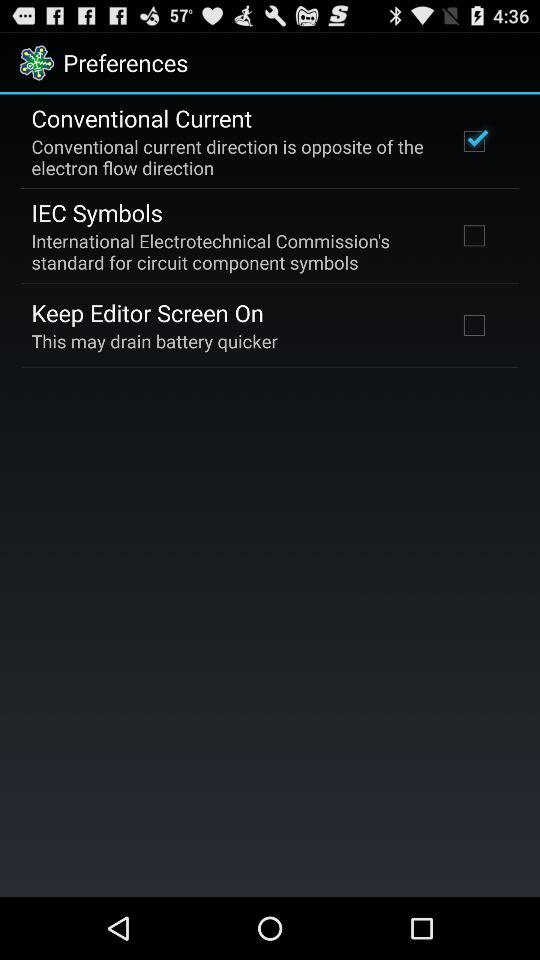What's the checked preference? The checked preference is "Conventional Current". 